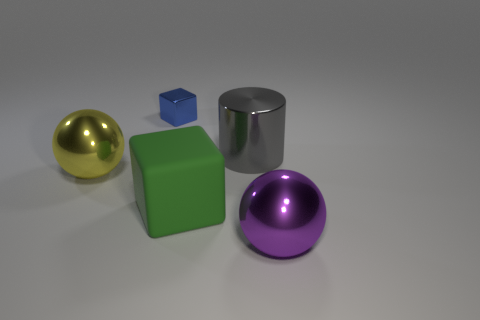Can you tell me which of these objects is the largest in size? Based on the image, the chrome cylinder looks to be the largest object. It stands out not only in height but also in diameter compared to the other geometric shapes like the spheres and cubes. 